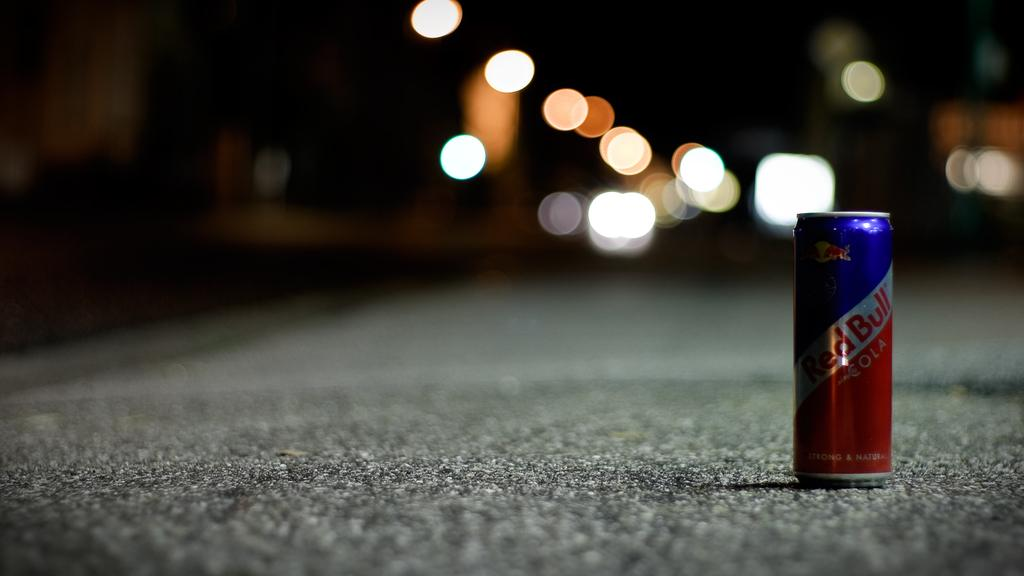<image>
Relay a brief, clear account of the picture shown. A lone can of Red Bull sits on a paved road. 